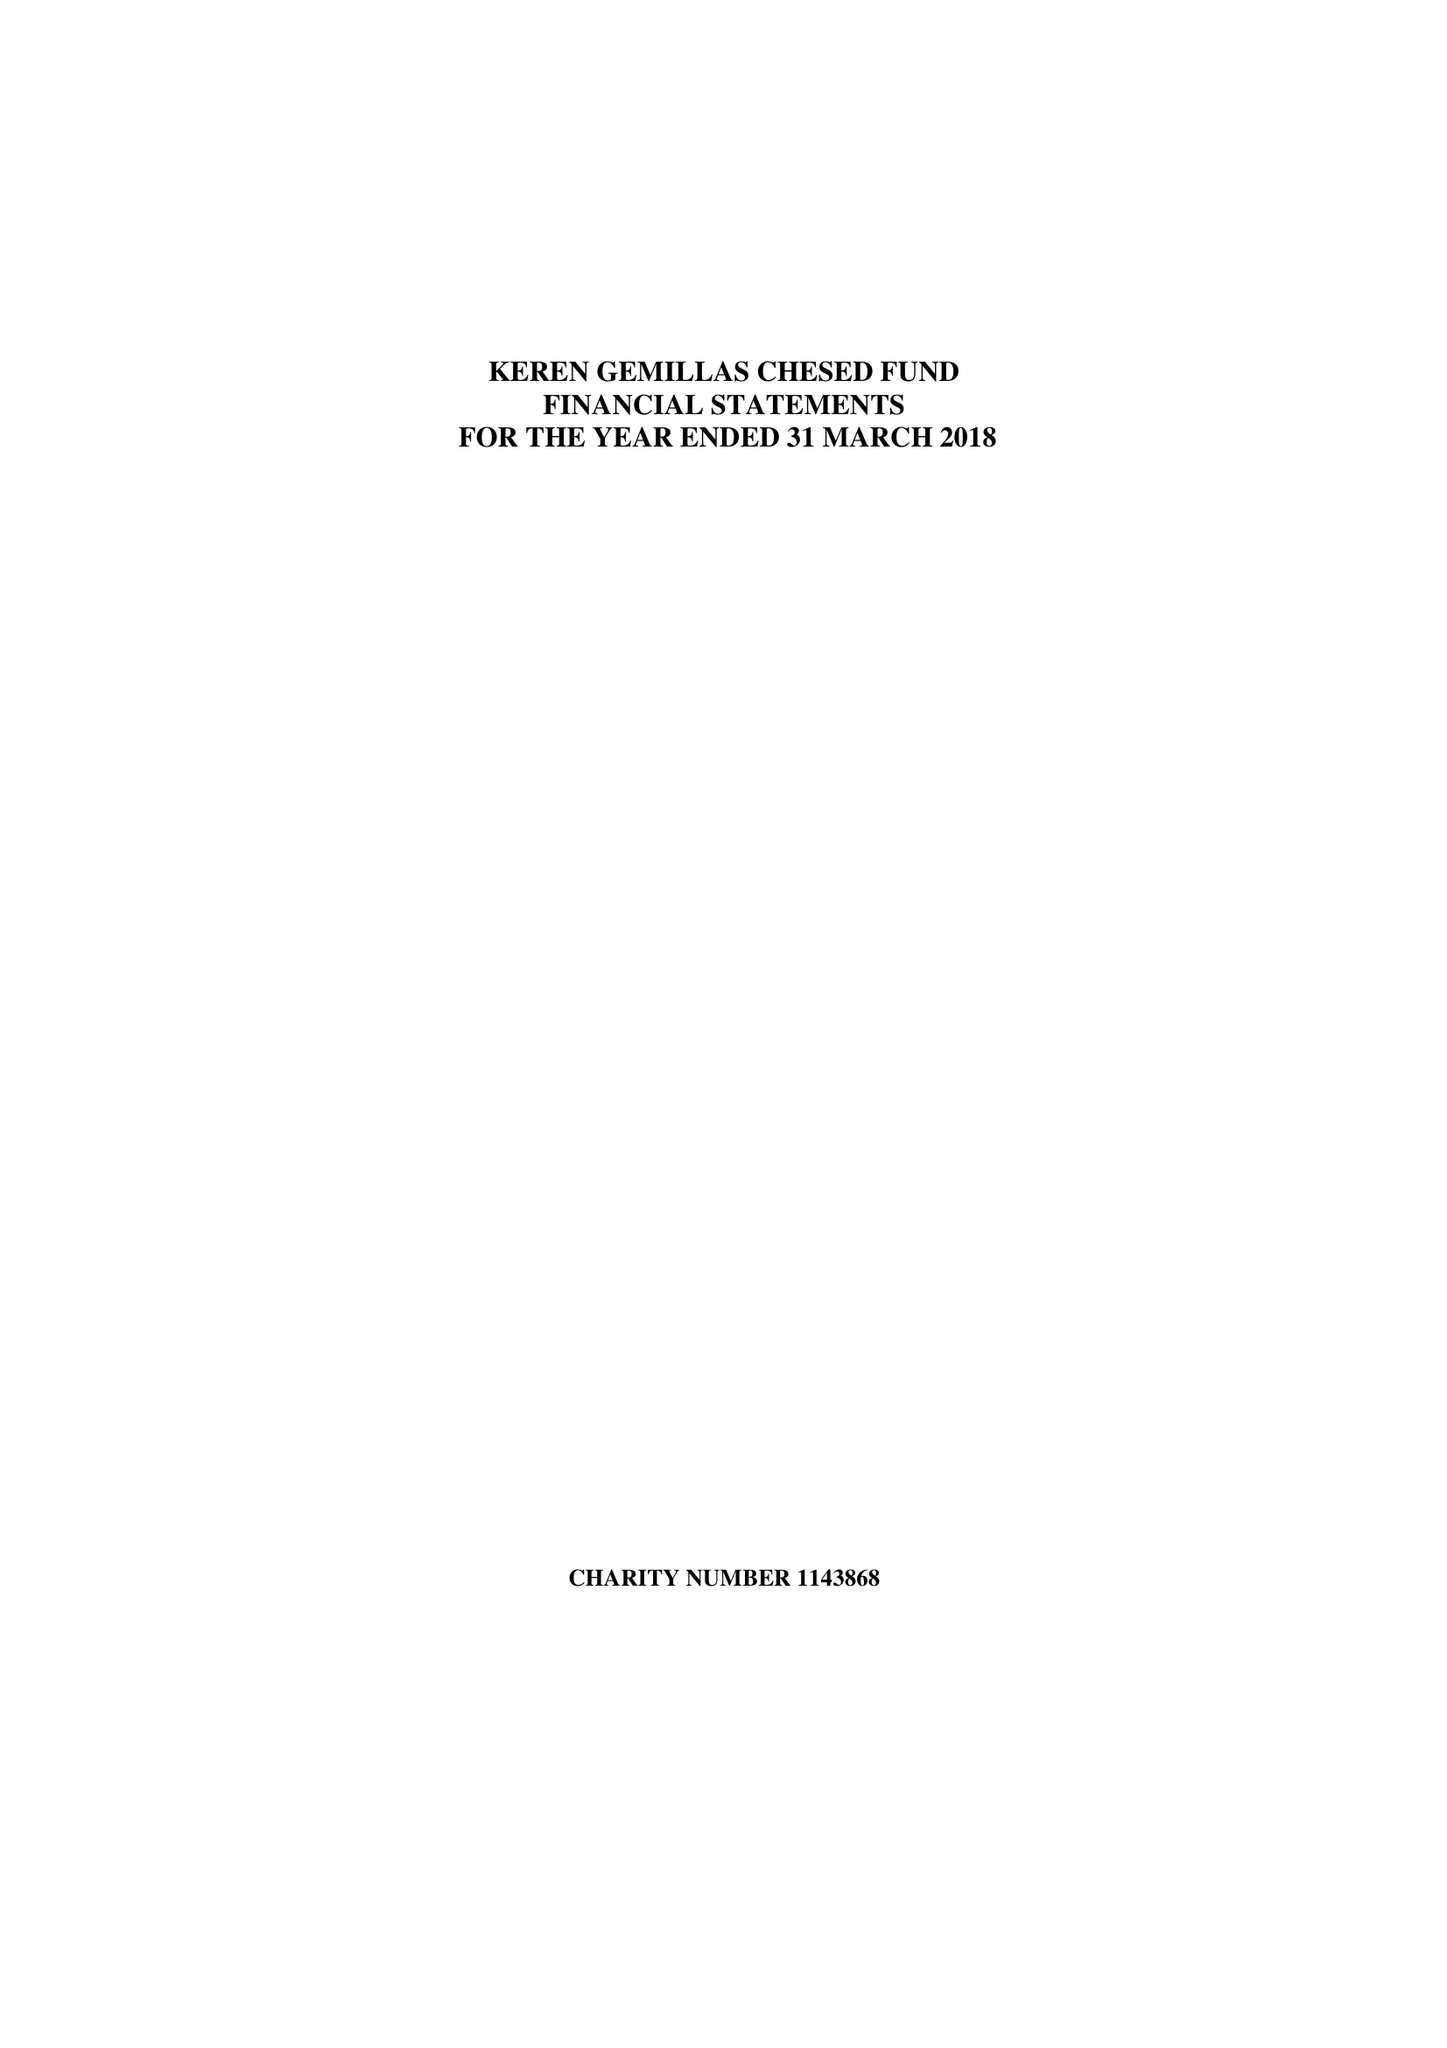What is the value for the address__post_town?
Answer the question using a single word or phrase. None 